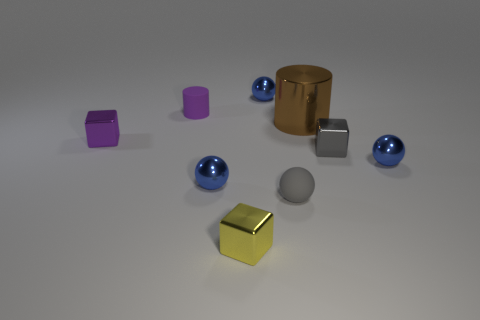Subtract all blue balls. How many were subtracted if there are1blue balls left? 2 Subtract all cyan cylinders. How many blue balls are left? 3 Subtract all blocks. How many objects are left? 6 Subtract all purple matte cylinders. Subtract all yellow metallic cubes. How many objects are left? 7 Add 2 gray metal blocks. How many gray metal blocks are left? 3 Add 5 big brown matte spheres. How many big brown matte spheres exist? 5 Subtract 2 blue spheres. How many objects are left? 7 